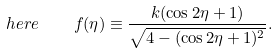Convert formula to latex. <formula><loc_0><loc_0><loc_500><loc_500>h e r e \quad f ( \eta ) \equiv \frac { k ( \cos 2 \eta + 1 ) } { \sqrt { 4 - ( \cos 2 \eta + 1 ) ^ { 2 } } } .</formula> 